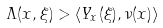Convert formula to latex. <formula><loc_0><loc_0><loc_500><loc_500>\Lambda ( x , \xi ) > \langle Y _ { x } ( \xi ) , \nu ( x ) \rangle</formula> 